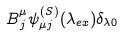<formula> <loc_0><loc_0><loc_500><loc_500>B ^ { \mu } _ { \, j } \psi _ { \mu j } ^ { ( S ) } ( \lambda _ { e x } ) \delta _ { \lambda 0 }</formula> 